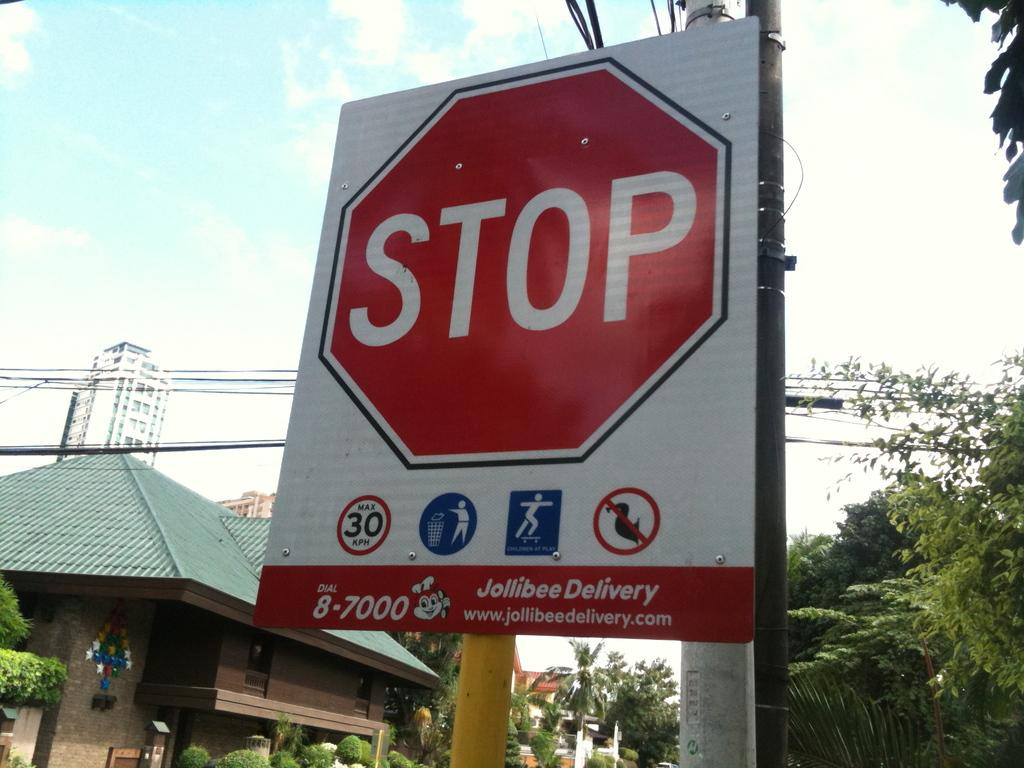<image>
Describe the image concisely. A stop sign with an ad for Jollibee Delivery on the bottom. 